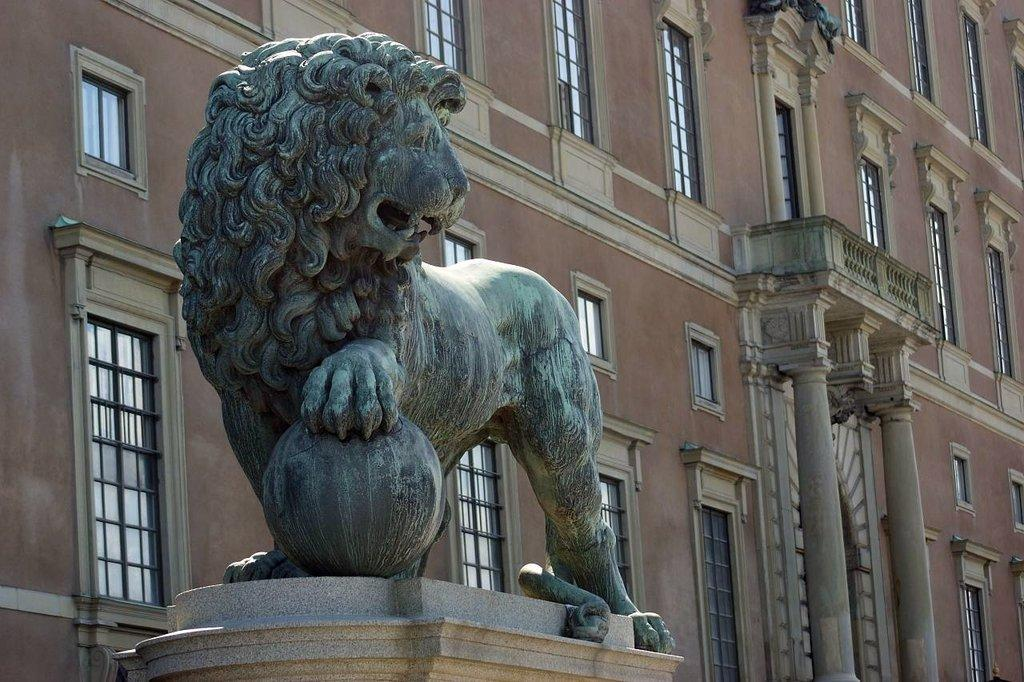What animal is present in the image? There is a lion in the image. What type of structure can be seen in the image? There is a building in the image. What feature of the building is mentioned in the facts? The building has windows. How many planes are parked near the building in the image? There is no mention of planes in the image, so we cannot determine the number of planes present. 